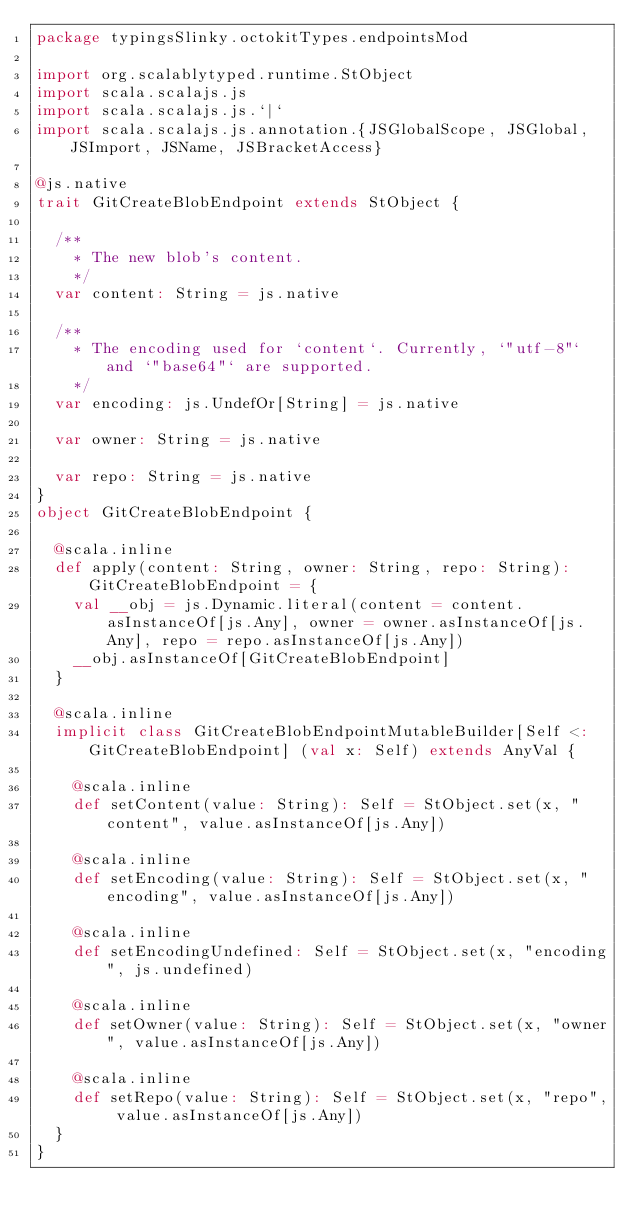Convert code to text. <code><loc_0><loc_0><loc_500><loc_500><_Scala_>package typingsSlinky.octokitTypes.endpointsMod

import org.scalablytyped.runtime.StObject
import scala.scalajs.js
import scala.scalajs.js.`|`
import scala.scalajs.js.annotation.{JSGlobalScope, JSGlobal, JSImport, JSName, JSBracketAccess}

@js.native
trait GitCreateBlobEndpoint extends StObject {
  
  /**
    * The new blob's content.
    */
  var content: String = js.native
  
  /**
    * The encoding used for `content`. Currently, `"utf-8"` and `"base64"` are supported.
    */
  var encoding: js.UndefOr[String] = js.native
  
  var owner: String = js.native
  
  var repo: String = js.native
}
object GitCreateBlobEndpoint {
  
  @scala.inline
  def apply(content: String, owner: String, repo: String): GitCreateBlobEndpoint = {
    val __obj = js.Dynamic.literal(content = content.asInstanceOf[js.Any], owner = owner.asInstanceOf[js.Any], repo = repo.asInstanceOf[js.Any])
    __obj.asInstanceOf[GitCreateBlobEndpoint]
  }
  
  @scala.inline
  implicit class GitCreateBlobEndpointMutableBuilder[Self <: GitCreateBlobEndpoint] (val x: Self) extends AnyVal {
    
    @scala.inline
    def setContent(value: String): Self = StObject.set(x, "content", value.asInstanceOf[js.Any])
    
    @scala.inline
    def setEncoding(value: String): Self = StObject.set(x, "encoding", value.asInstanceOf[js.Any])
    
    @scala.inline
    def setEncodingUndefined: Self = StObject.set(x, "encoding", js.undefined)
    
    @scala.inline
    def setOwner(value: String): Self = StObject.set(x, "owner", value.asInstanceOf[js.Any])
    
    @scala.inline
    def setRepo(value: String): Self = StObject.set(x, "repo", value.asInstanceOf[js.Any])
  }
}
</code> 